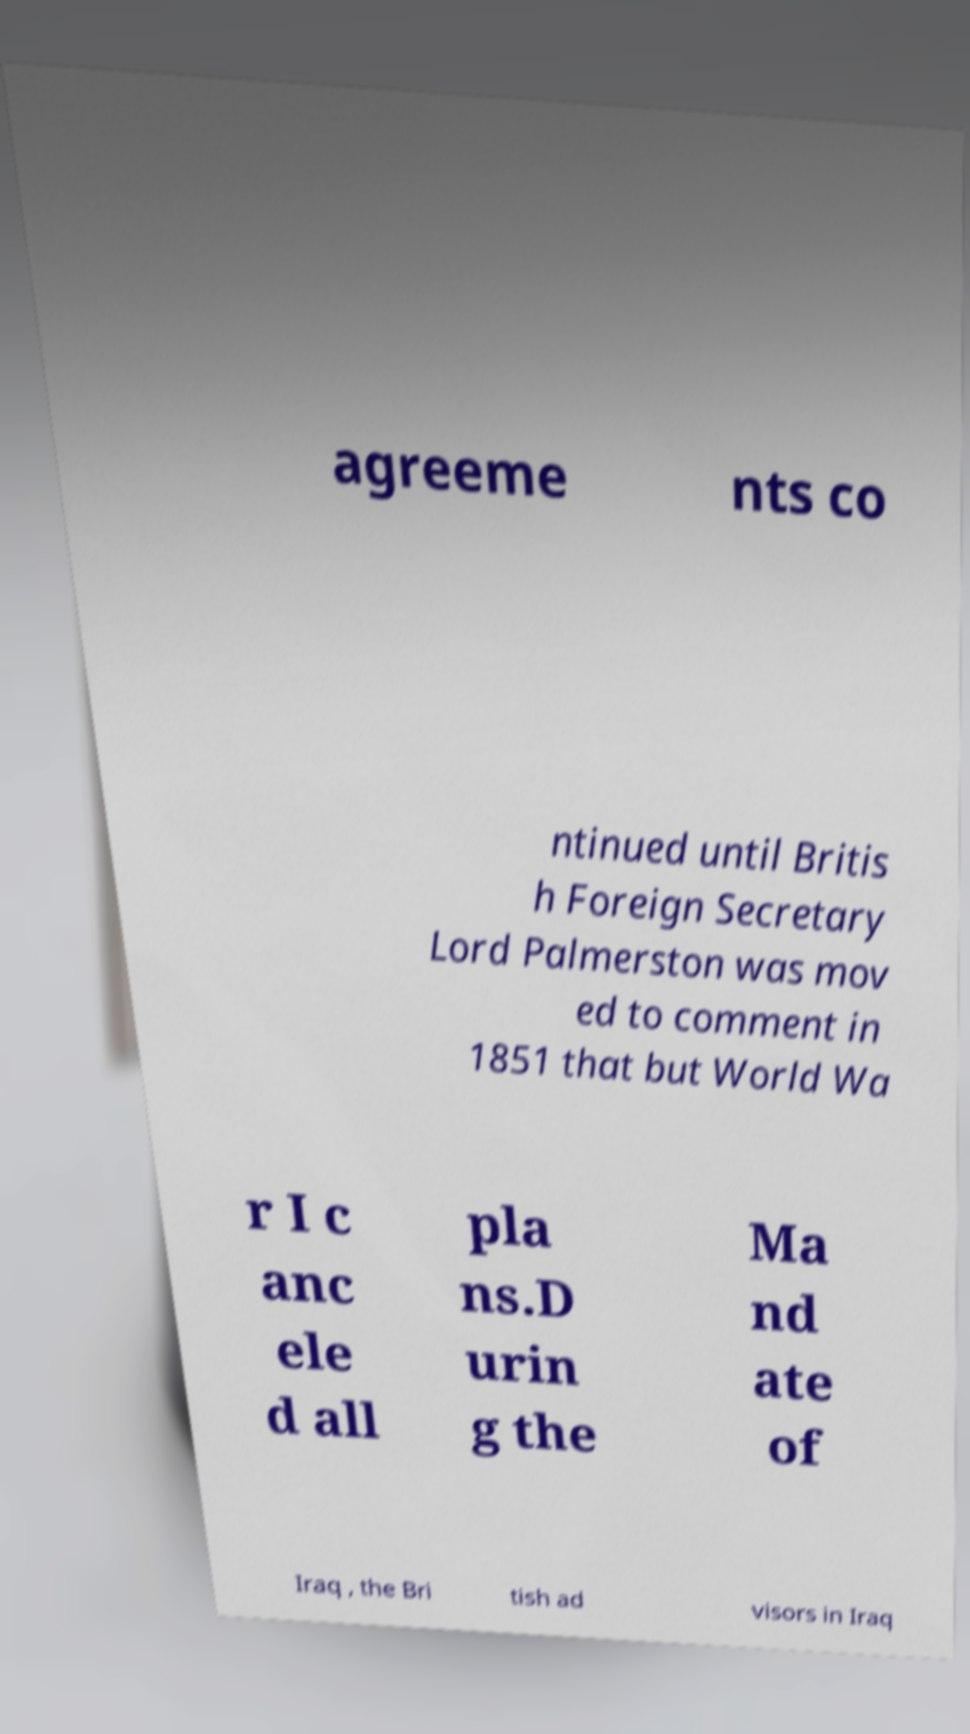What messages or text are displayed in this image? I need them in a readable, typed format. agreeme nts co ntinued until Britis h Foreign Secretary Lord Palmerston was mov ed to comment in 1851 that but World Wa r I c anc ele d all pla ns.D urin g the Ma nd ate of Iraq , the Bri tish ad visors in Iraq 